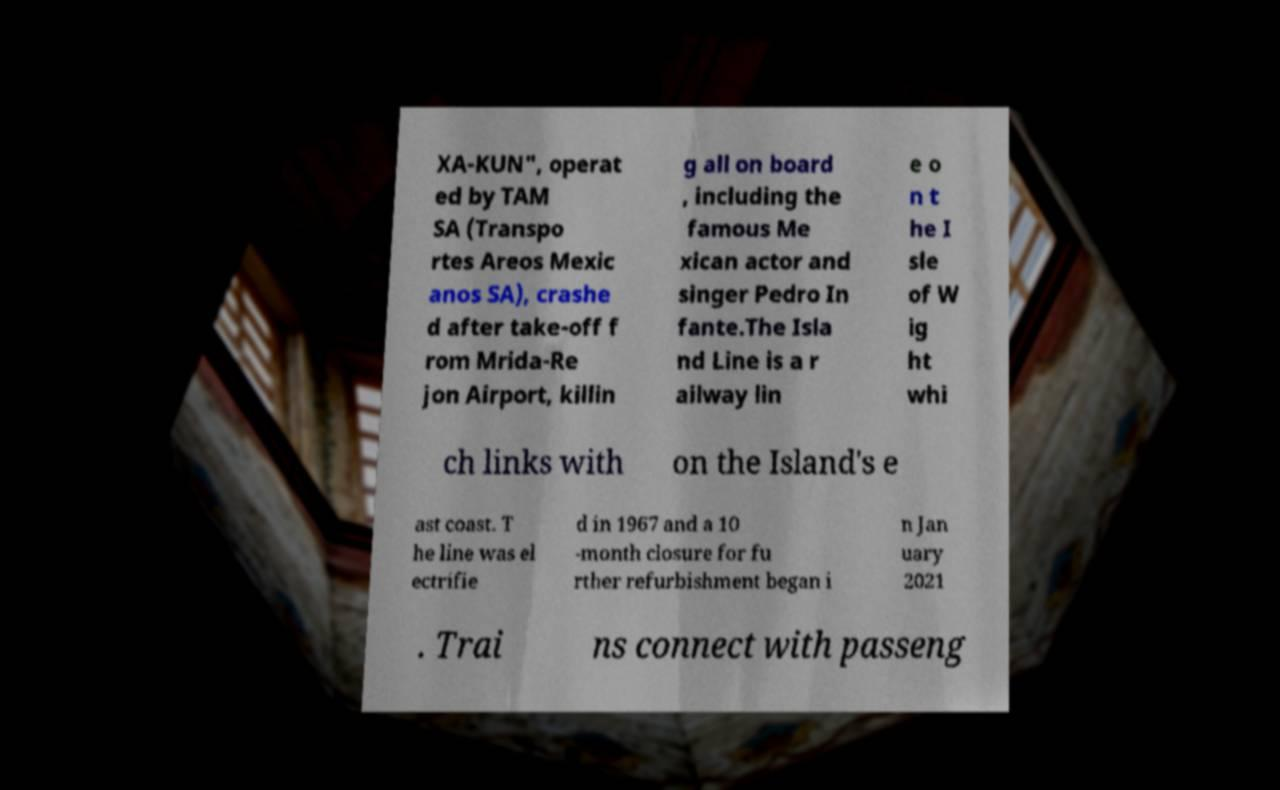Could you assist in decoding the text presented in this image and type it out clearly? XA-KUN", operat ed by TAM SA (Transpo rtes Areos Mexic anos SA), crashe d after take-off f rom Mrida-Re jon Airport, killin g all on board , including the famous Me xican actor and singer Pedro In fante.The Isla nd Line is a r ailway lin e o n t he I sle of W ig ht whi ch links with on the Island's e ast coast. T he line was el ectrifie d in 1967 and a 10 -month closure for fu rther refurbishment began i n Jan uary 2021 . Trai ns connect with passeng 